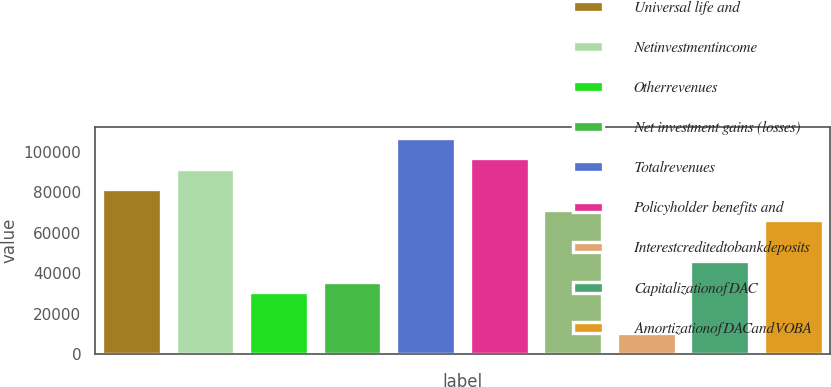<chart> <loc_0><loc_0><loc_500><loc_500><bar_chart><fcel>Universal life and<fcel>Netinvestmentincome<fcel>Otherrevenues<fcel>Net investment gains (losses)<fcel>Totalrevenues<fcel>Policyholder benefits and<fcel>Unnamed: 6<fcel>Interestcreditedtobankdeposits<fcel>CapitalizationofDAC<fcel>AmortizationofDACandVOBA<nl><fcel>81533<fcel>91716<fcel>30618<fcel>35709.5<fcel>106990<fcel>96807.5<fcel>71350<fcel>10252<fcel>45892.5<fcel>66258.5<nl></chart> 